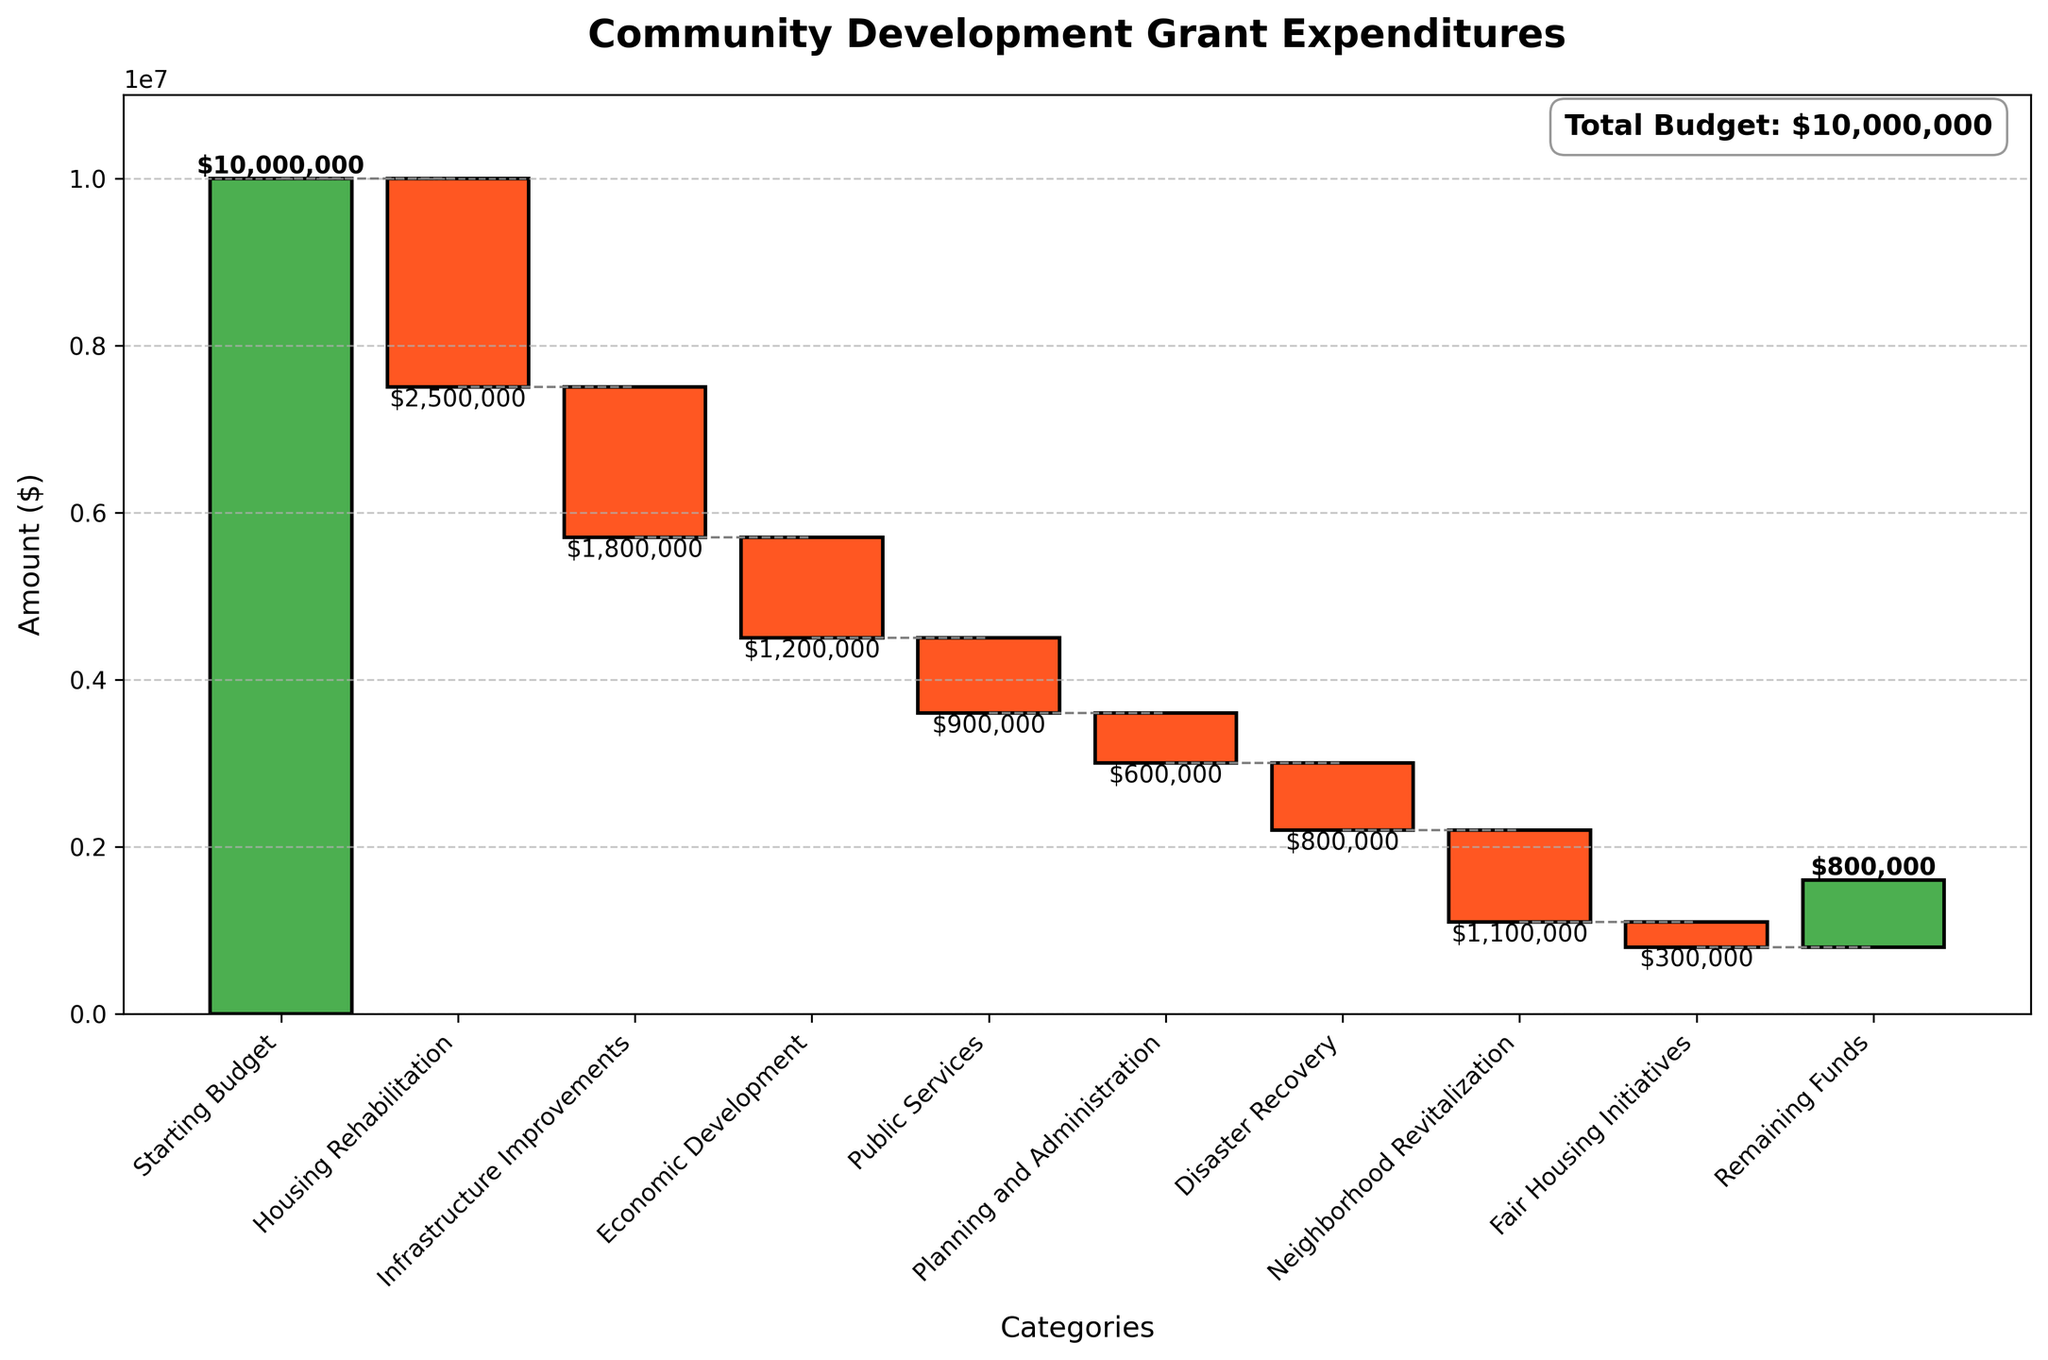What's the title of the chart? The title is usually displayed at the top of the chart. In this chart, the title is written in bold and large font.
Answer: Community Development Grant Expenditures What color is used to represent negative values in the chart? Negative values in the chart are represented by a specific color. By examining the bars that decrease, we can identify the color.
Answer: Red How many categories are shown in the chart? To determine the number of categories, we count each label on the x-axis. Each category corresponds to one bar.
Answer: 9 Which category has the highest expenditure? The category with the highest expenditure will have the longest red bar pointing downwards.
Answer: Housing Rehabilitation What is the total budget before any expenditures? The total budget before expenditures is shown as the first value on the y-axis and is labeled in the chart with a green bar.
Answer: $10,000,000 What is the remaining budget after all expenditures? The remaining budget is indicated by the last value on the chart, also represented by a green bar.
Answer: $800,000 How much did Housing Rehabilitation cost the budget? The amount spent on Housing Rehabilitation is shown by the length of the red bar associated with this category. This value can also be found in the text label above the bar.
Answer: $2,500,000 What is the total expenditure on Disaster Recovery and Neighborhood Revitalization combined? To find the total expenditure, add the amounts spent on Disaster Recovery and Neighborhood Revitalization. Examine the corresponding bars and sum their values.
Answer: $1,900,000 Which category shows the smallest expenditure? The category with the smallest expenditure will have the shortest red bar.
Answer: Fair Housing Initiatives How does the expenditure on Economic Development compare to Infrastructure Improvements? Compare the lengths of the red bars for Economic Development and Infrastructure Improvements to determine which is larger.
Answer: Economic Development expenditure is $1,200,000 and Infrastructure Improvements is $1,800,000. Economic Development is less 